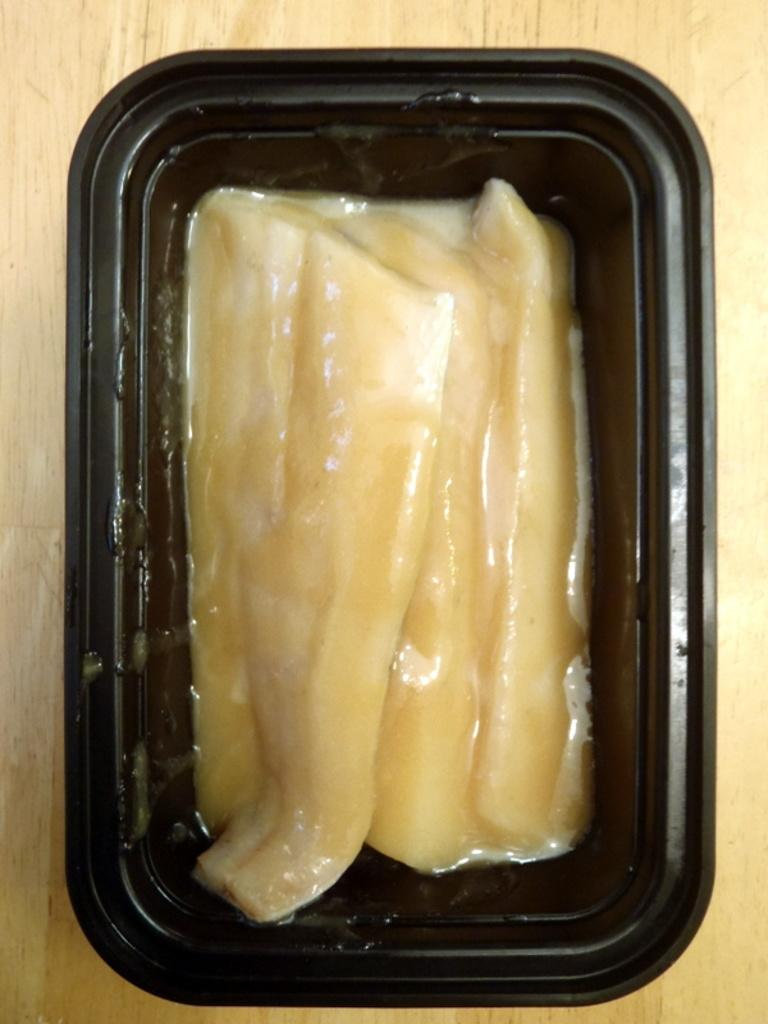What is the color of the box containing food in the image? The box is black. What type of surface is the box placed on? The box is placed on a wooden surface. Are there any plants growing inside the black color box in the image? No, there are no plants visible in the image; the box contains food. 